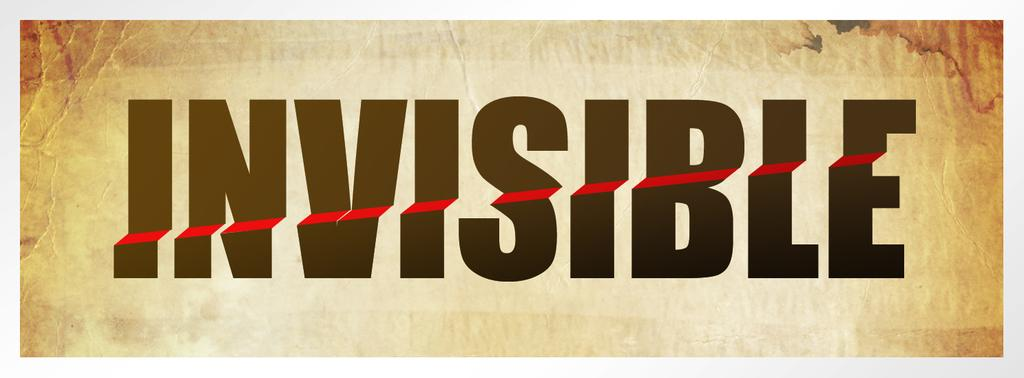<image>
Present a compact description of the photo's key features. Invisible in black block font with red line crossing the word. 